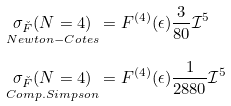Convert formula to latex. <formula><loc_0><loc_0><loc_500><loc_500>\underset { N e w t o n - C o t e s } { \sigma _ { \check { F } } ( N = 4 ) } & = F ^ { ( 4 ) } ( \epsilon ) \frac { 3 } { 8 0 } \mathcal { I } ^ { 5 } \\ \underset { C o m p . S i m p s o n } { \sigma _ { \check { F } } ( N = 4 ) } & = F ^ { ( 4 ) } ( \epsilon ) \frac { 1 } { 2 8 8 0 } \mathcal { I } ^ { 5 }</formula> 